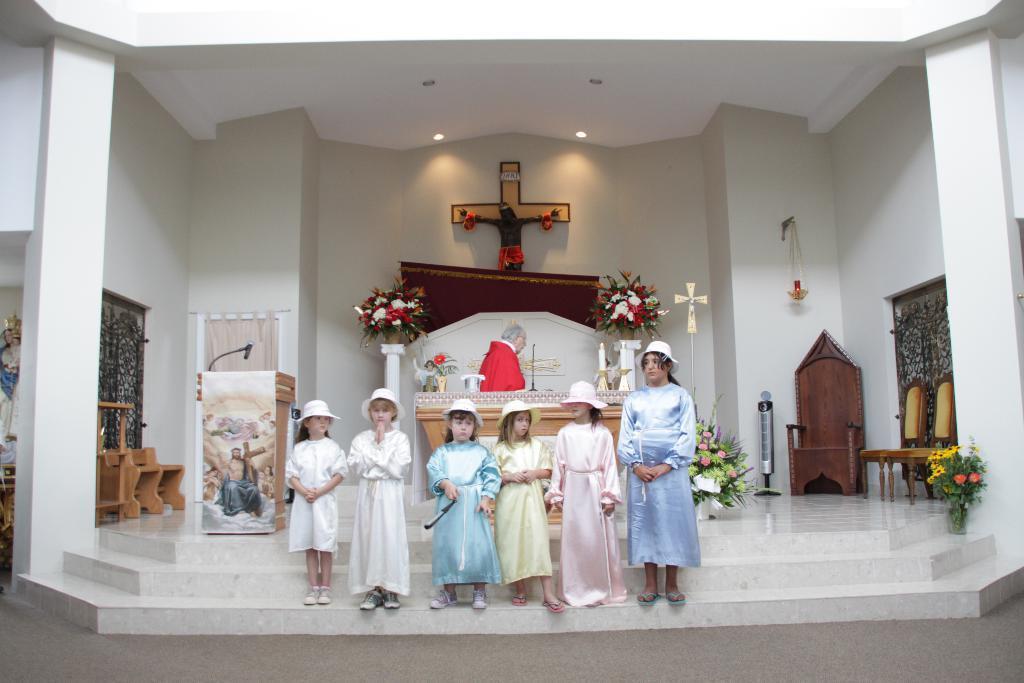How would you summarize this image in a sentence or two? In this image there are a few kids and a woman standing on the stairs, behind them there are wooden chairs, podium, flower bouquets, on the podium there is a mic, behind the kids there is a person, in front of the person there are some objects and a mic on a wooden podium, behind the person on the wall there is a cross, flowers and a banner, at the top of the image there are two lamps, on the either side of the stairs there are pillars and some statues. 